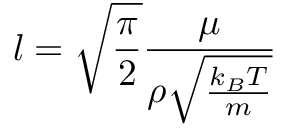<formula> <loc_0><loc_0><loc_500><loc_500>l = \sqrt { \frac { \pi } { 2 } } \frac { \mu } { \rho \sqrt { \frac { k _ { B } T } { m } } }</formula> 